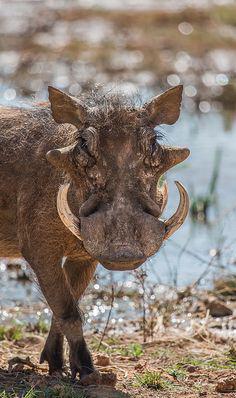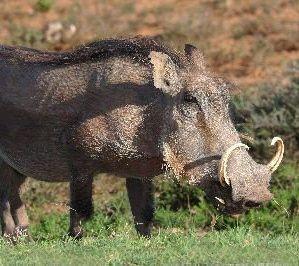The first image is the image on the left, the second image is the image on the right. For the images displayed, is the sentence "The warthog in the image on the left is facing the camera." factually correct? Answer yes or no. Yes. 